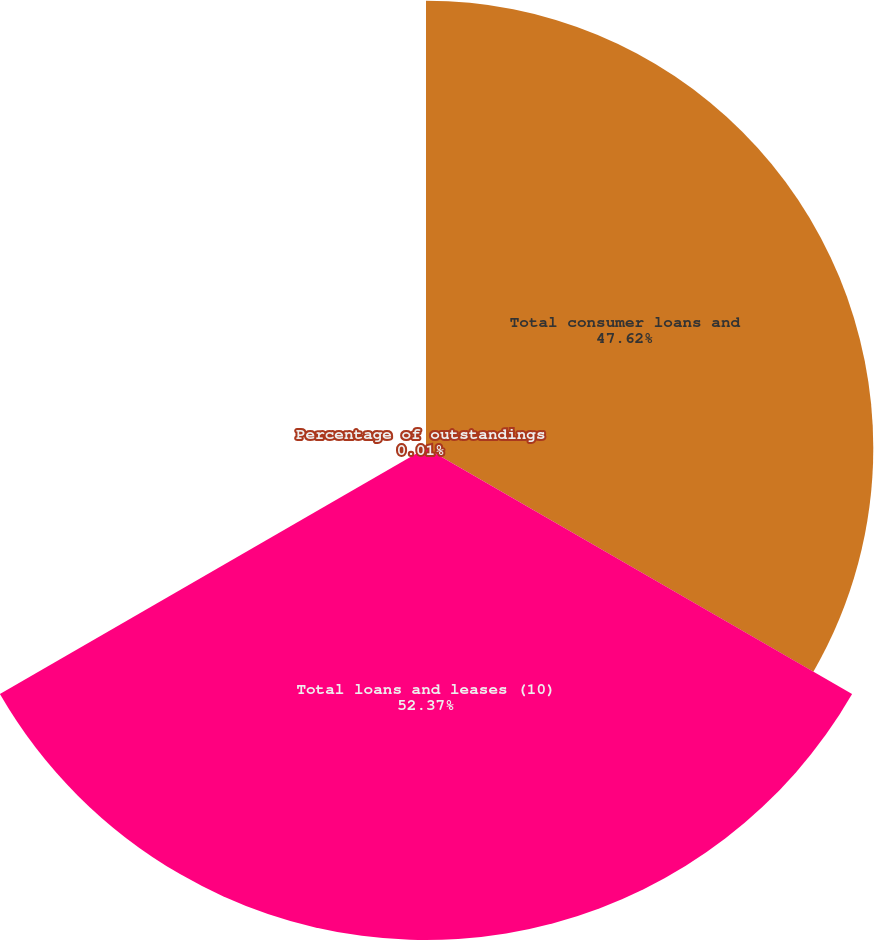Convert chart. <chart><loc_0><loc_0><loc_500><loc_500><pie_chart><fcel>Total consumer loans and<fcel>Total loans and leases (10)<fcel>Percentage of outstandings<nl><fcel>47.62%<fcel>52.38%<fcel>0.01%<nl></chart> 